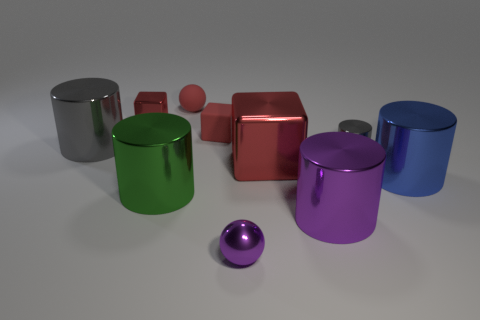Subtract all big blue cylinders. How many cylinders are left? 4 Add 1 red metal blocks. How many red metal blocks exist? 3 Subtract all red balls. How many balls are left? 1 Subtract 3 red cubes. How many objects are left? 7 Subtract all cubes. How many objects are left? 7 Subtract 1 cylinders. How many cylinders are left? 4 Subtract all brown cylinders. Subtract all red blocks. How many cylinders are left? 5 Subtract all yellow spheres. How many green cylinders are left? 1 Subtract all gray metal things. Subtract all blue metallic cylinders. How many objects are left? 7 Add 5 shiny balls. How many shiny balls are left? 6 